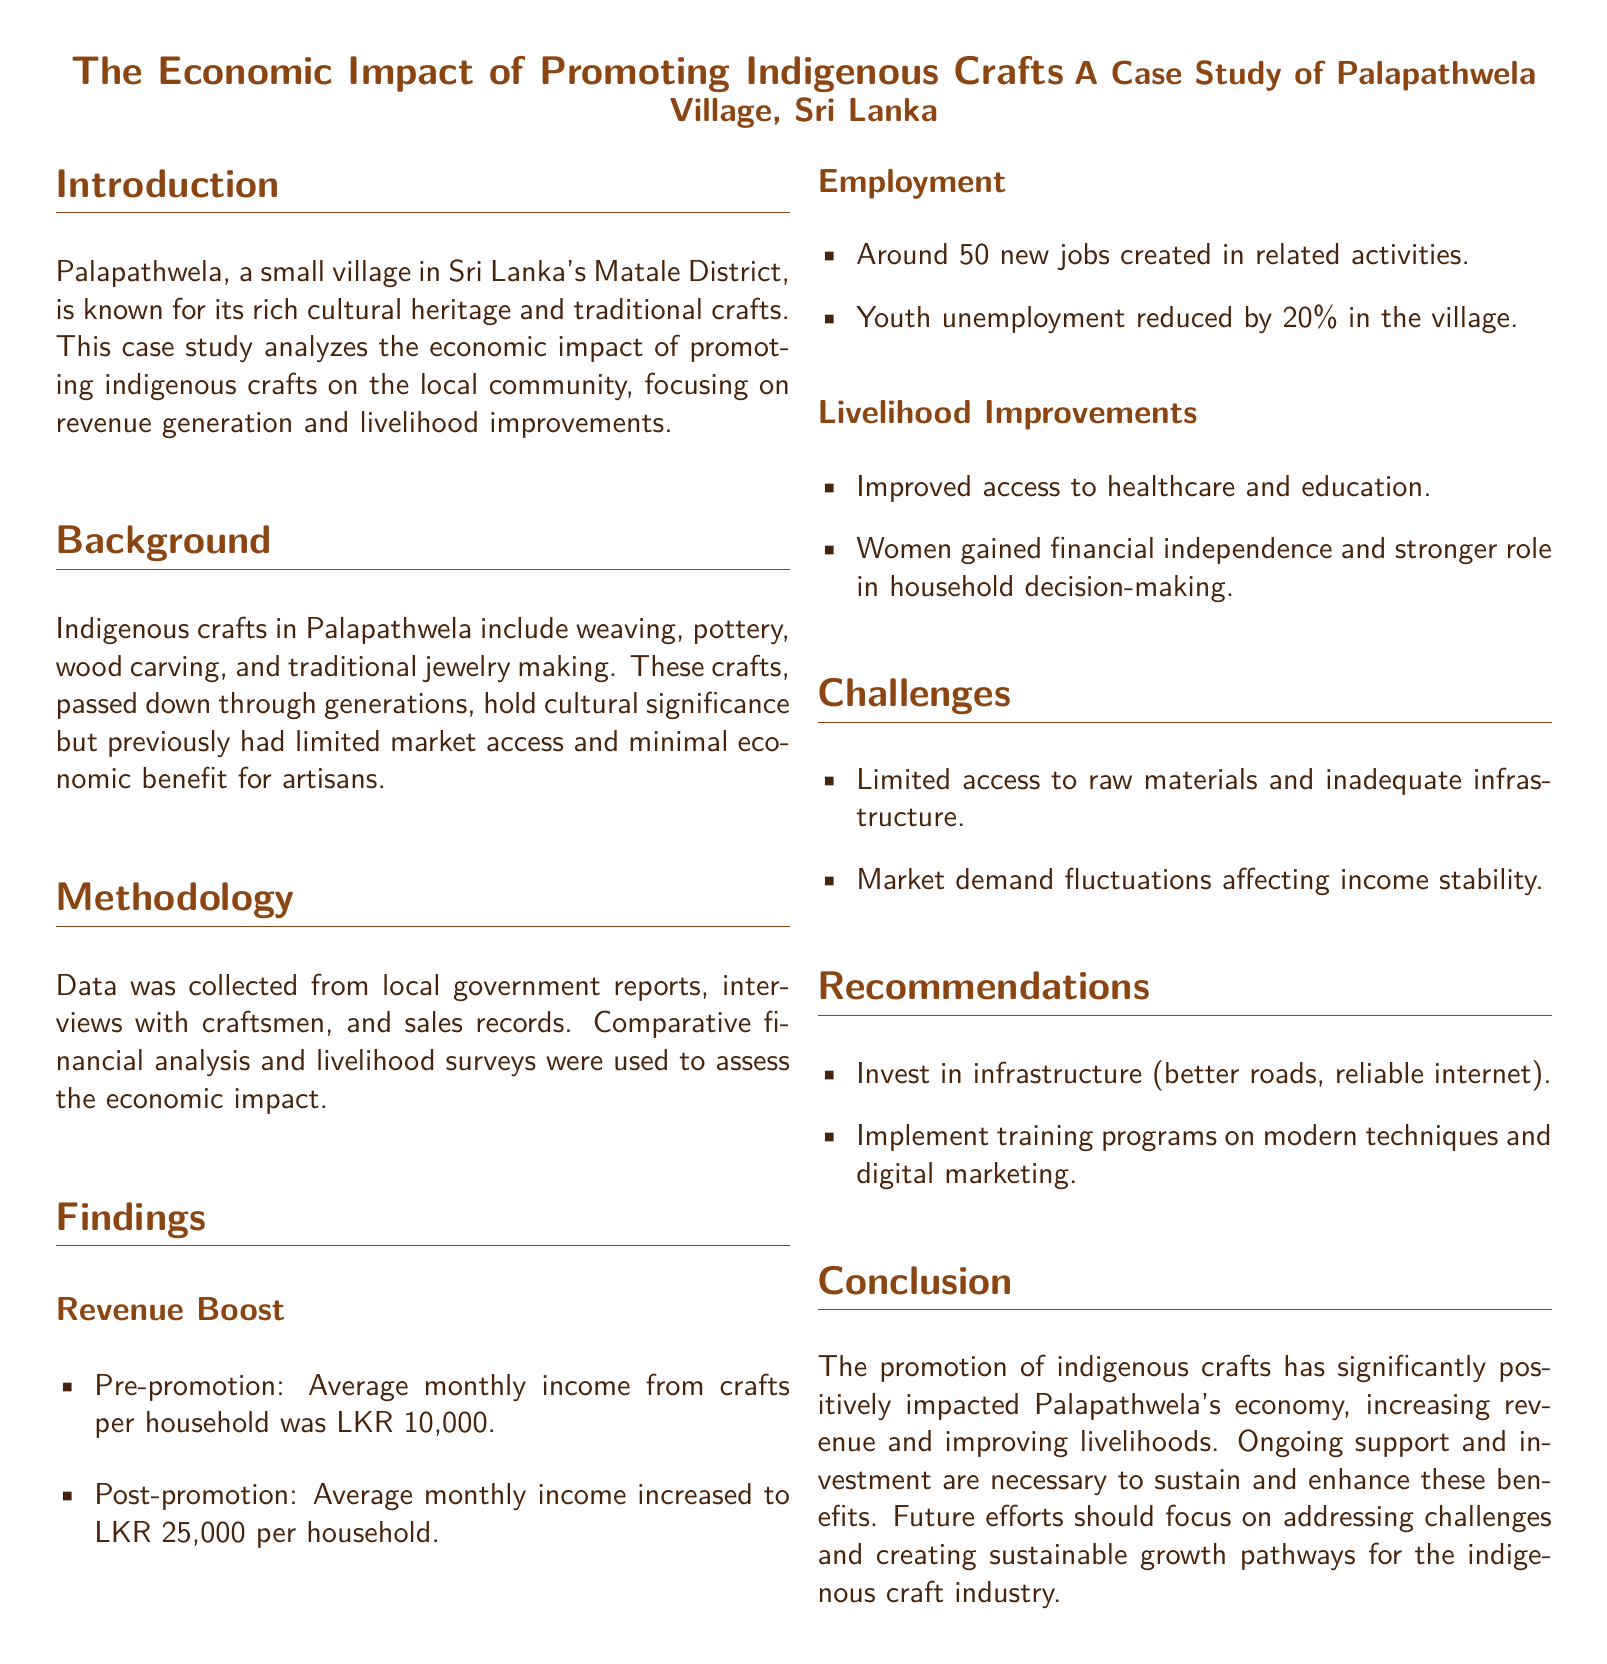what is the average monthly income from crafts per household pre-promotion? The document states that the average monthly income from crafts per household before promotion was LKR 10,000.
Answer: LKR 10,000 what is the average monthly income from crafts per household post-promotion? According to the case study, after the promotion, the average monthly income increased to LKR 25,000 per household.
Answer: LKR 25,000 how many new jobs were created in related activities? The findings indicate that around 50 new jobs were created in activities related to indigenous crafts.
Answer: 50 what percentage did youth unemployment decrease in the village? The document reports that youth unemployment was reduced by 20% in Palapathwela village.
Answer: 20% what are two types of indigenous crafts mentioned? The case study lists weaving and pottery as two types of indigenous crafts practiced in the village.
Answer: weaving, pottery what was one significant benefit for women in the community? The case study highlights that women gained financial independence and a stronger role in household decision-making as a significant benefit.
Answer: financial independence what are two challenges faced by the artisans? The document mentions limited access to raw materials and inadequate infrastructure as two challenges faced by artisans.
Answer: raw materials, infrastructure what is one recommendation made in the document? The recommendations suggest investing in infrastructure, such as better roads and reliable internet, among other strategies.
Answer: invest in infrastructure what is the main focus of the case study? The primary focus of the case study is analyzing the economic impact of promoting indigenous crafts on the local community.
Answer: economic impact 